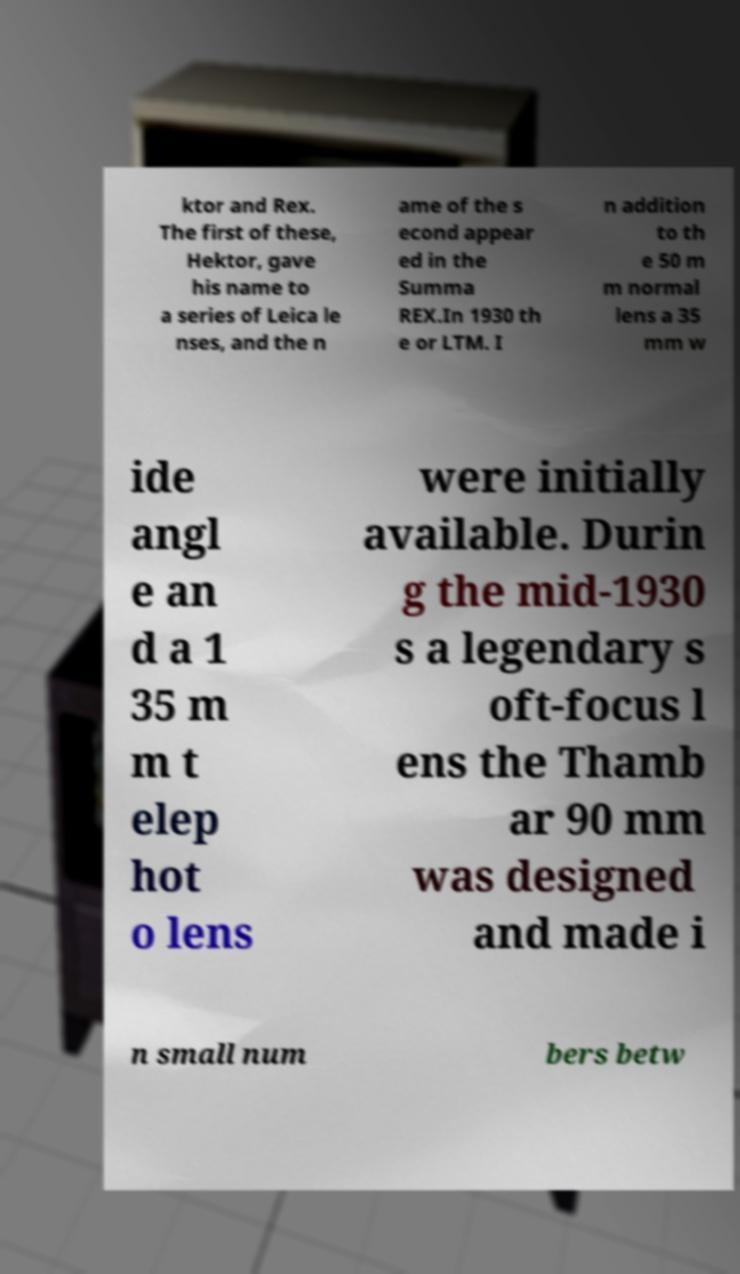Can you read and provide the text displayed in the image?This photo seems to have some interesting text. Can you extract and type it out for me? ktor and Rex. The first of these, Hektor, gave his name to a series of Leica le nses, and the n ame of the s econd appear ed in the Summa REX.In 1930 th e or LTM. I n addition to th e 50 m m normal lens a 35 mm w ide angl e an d a 1 35 m m t elep hot o lens were initially available. Durin g the mid-1930 s a legendary s oft-focus l ens the Thamb ar 90 mm was designed and made i n small num bers betw 